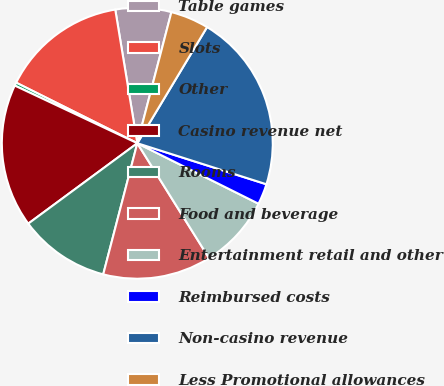Convert chart to OTSL. <chart><loc_0><loc_0><loc_500><loc_500><pie_chart><fcel>Table games<fcel>Slots<fcel>Other<fcel>Casino revenue net<fcel>Rooms<fcel>Food and beverage<fcel>Entertainment retail and other<fcel>Reimbursed costs<fcel>Non-casino revenue<fcel>Less Promotional allowances<nl><fcel>6.65%<fcel>15.02%<fcel>0.38%<fcel>17.11%<fcel>10.84%<fcel>12.93%<fcel>8.75%<fcel>2.47%<fcel>21.29%<fcel>4.56%<nl></chart> 